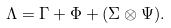Convert formula to latex. <formula><loc_0><loc_0><loc_500><loc_500>\Lambda = \Gamma + \Phi + ( \Sigma \otimes \Psi ) .</formula> 